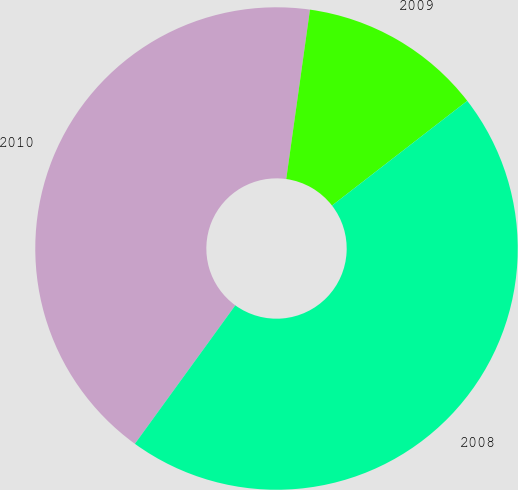Convert chart to OTSL. <chart><loc_0><loc_0><loc_500><loc_500><pie_chart><fcel>2010<fcel>2009<fcel>2008<nl><fcel>42.23%<fcel>12.3%<fcel>45.47%<nl></chart> 